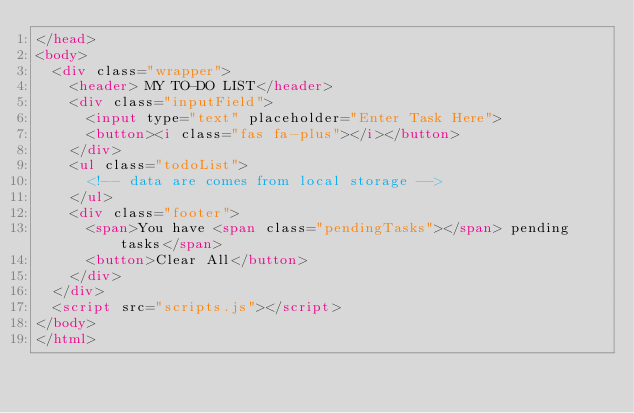Convert code to text. <code><loc_0><loc_0><loc_500><loc_500><_HTML_></head>
<body>
  <div class="wrapper">
    <header> MY TO-DO LIST</header>
    <div class="inputField">
      <input type="text" placeholder="Enter Task Here">
      <button><i class="fas fa-plus"></i></button>
    </div>
    <ul class="todoList">
      <!-- data are comes from local storage -->
    </ul>
    <div class="footer">
      <span>You have <span class="pendingTasks"></span> pending tasks</span>
      <button>Clear All</button>
    </div>
  </div>
  <script src="scripts.js"></script>
</body>
</html>
</code> 